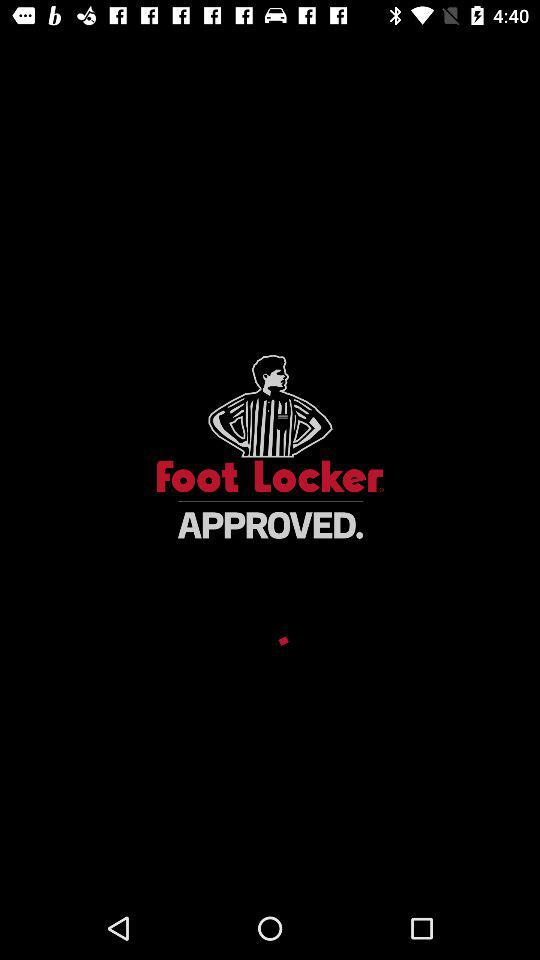What is the app name? The app name is "Beacon". 